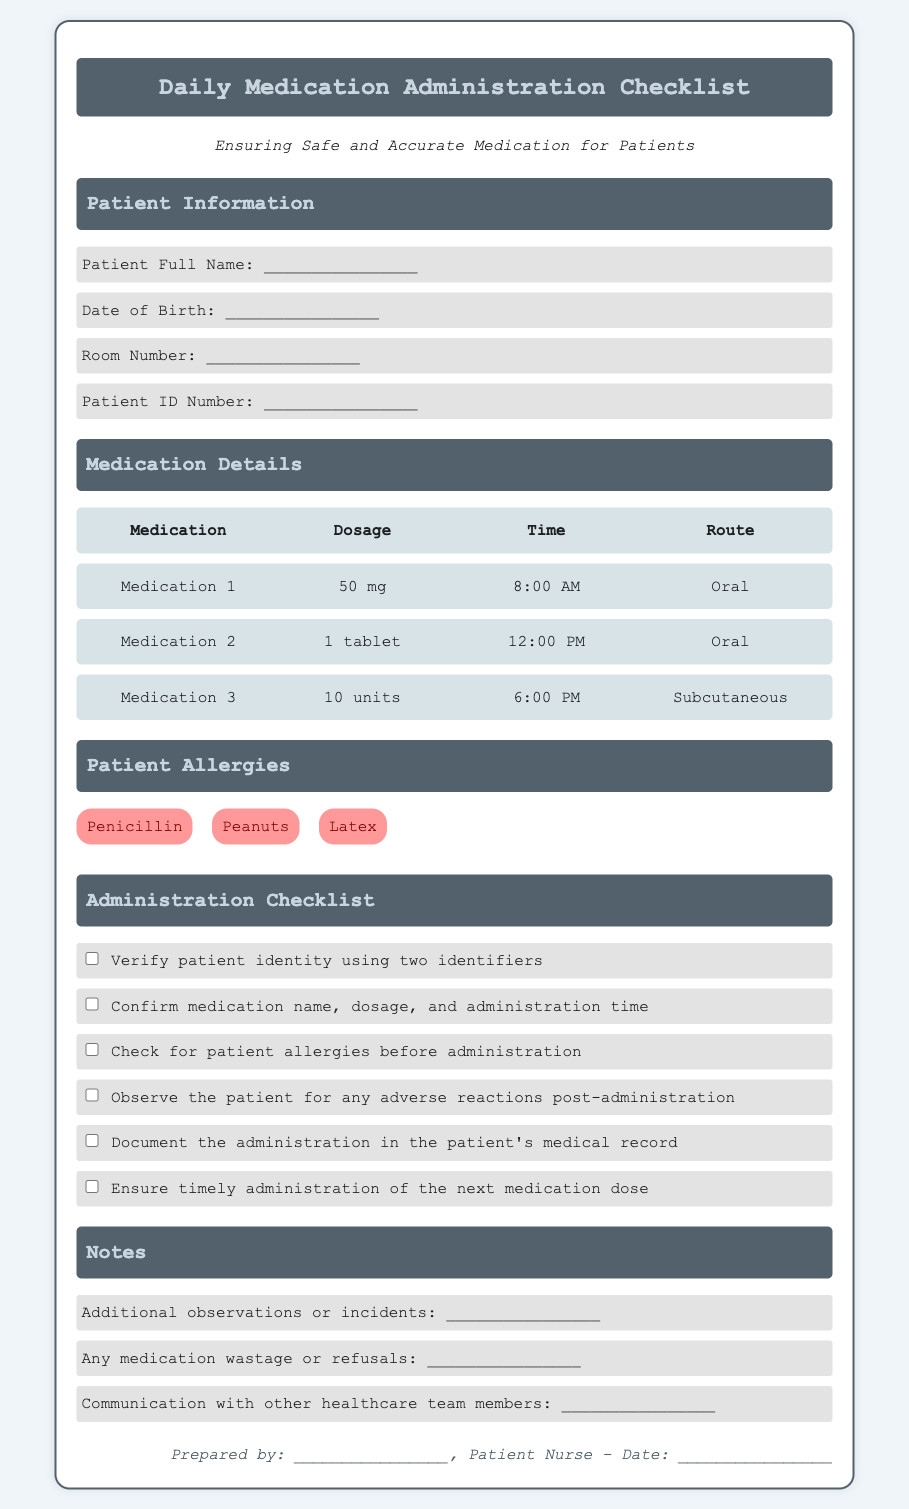What is the patient’s full name? The patient’s full name is to be filled in the checklist under "Patient Information."
Answer: ________________ What time is Medication 2 administered? Medication 2 is scheduled for administration at 12:00 PM as stated in the Medication Details section.
Answer: 12:00 PM How many units is Medication 3? According to the checklist, Medication 3 is administered in a dosage of 10 units.
Answer: 10 units What is one of the patient’s allergies? The document lists several allergies, such as "Penicillin," which is highlighted in the Patient Allergies section.
Answer: Penicillin What should be verified to ensure medication safety? The checklist states that the patient identity should be verified using two identifiers for safe medication administration.
Answer: Patient identity What is included in the Administration Checklist? The Administration Checklist includes multiple steps, one of which is checking for patient allergies before administration.
Answer: Check for patient allergies What route is used for Medication 3? The route for Medication 3 is listed as Subcutaneous in the Medication Details section.
Answer: Subcutaneous What does the footer indicate? The footer indicates who prepared the document and the date it was prepared, to ensure accountability in the checklist.
Answer: Prepared by: ________________ 